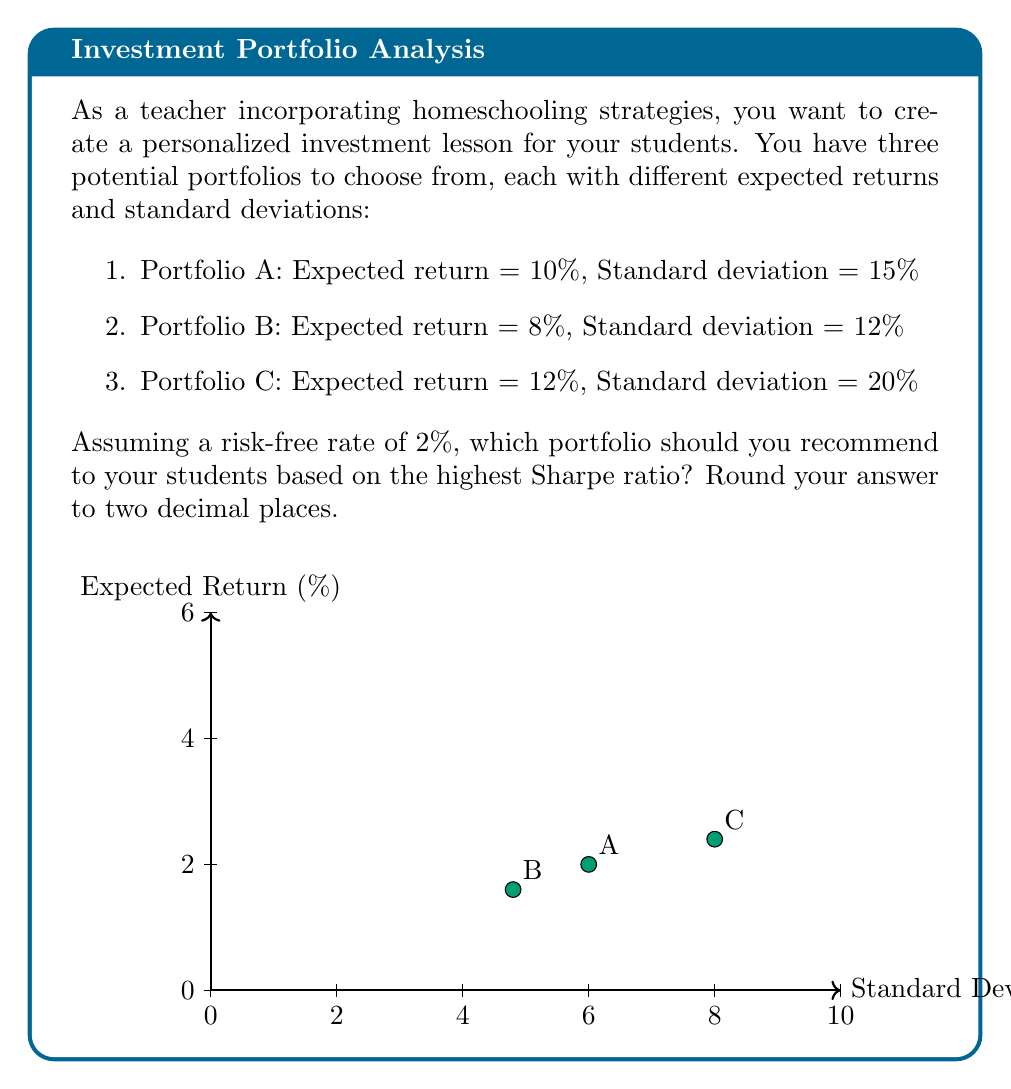Teach me how to tackle this problem. To determine the optimal portfolio using the Sharpe ratio, we need to calculate the Sharpe ratio for each portfolio and choose the one with the highest value. The Sharpe ratio is calculated using the following formula:

$$ \text{Sharpe Ratio} = \frac{R_p - R_f}{\sigma_p} $$

Where:
$R_p$ = Expected portfolio return
$R_f$ = Risk-free rate
$\sigma_p$ = Portfolio standard deviation

Let's calculate the Sharpe ratio for each portfolio:

1. Portfolio A:
$$ \text{Sharpe Ratio}_A = \frac{10\% - 2\%}{15\%} = \frac{8\%}{15\%} = 0.5333 $$

2. Portfolio B:
$$ \text{Sharpe Ratio}_B = \frac{8\% - 2\%}{12\%} = \frac{6\%}{12\%} = 0.5000 $$

3. Portfolio C:
$$ \text{Sharpe Ratio}_C = \frac{12\% - 2\%}{20\%} = \frac{10\%}{20\%} = 0.5000 $$

Rounding to two decimal places:
- Portfolio A: 0.53
- Portfolio B: 0.50
- Portfolio C: 0.50

Portfolio A has the highest Sharpe ratio, indicating the best risk-adjusted return.
Answer: Portfolio A (Sharpe ratio: 0.53) 